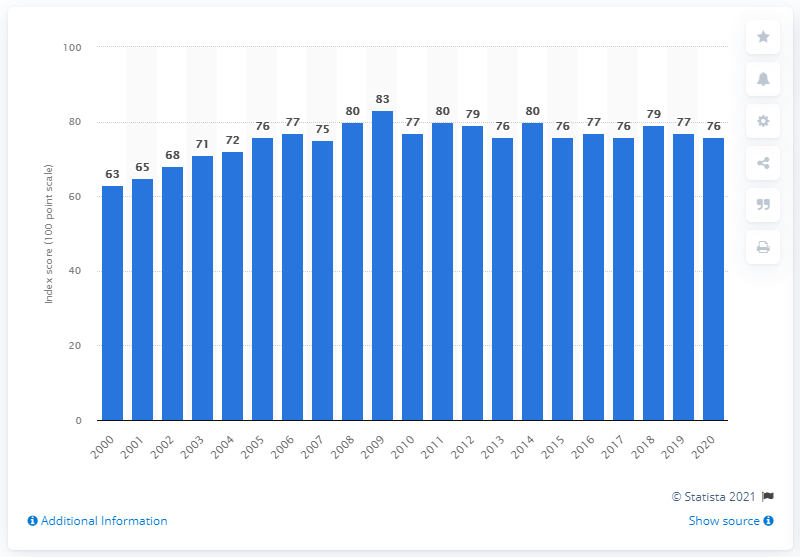Indicate a few pertinent items in this graphic. The most recent customer satisfaction score was 76. 